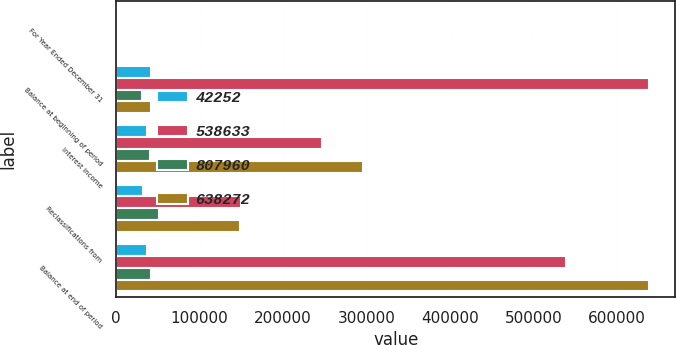Convert chart. <chart><loc_0><loc_0><loc_500><loc_500><stacked_bar_chart><ecel><fcel>For Year Ended December 31<fcel>Balance at beginning of period<fcel>Interest income<fcel>Reclassifications from<fcel>Balance at end of period<nl><fcel>42252<fcel>2013<fcel>42252<fcel>36727<fcel>31705<fcel>37230<nl><fcel>538633<fcel>2013<fcel>638272<fcel>247295<fcel>149595<fcel>538633<nl><fcel>807960<fcel>2012<fcel>30805<fcel>40551<fcel>51998<fcel>42252<nl><fcel>638272<fcel>2012<fcel>42252<fcel>295654<fcel>148490<fcel>638272<nl></chart> 